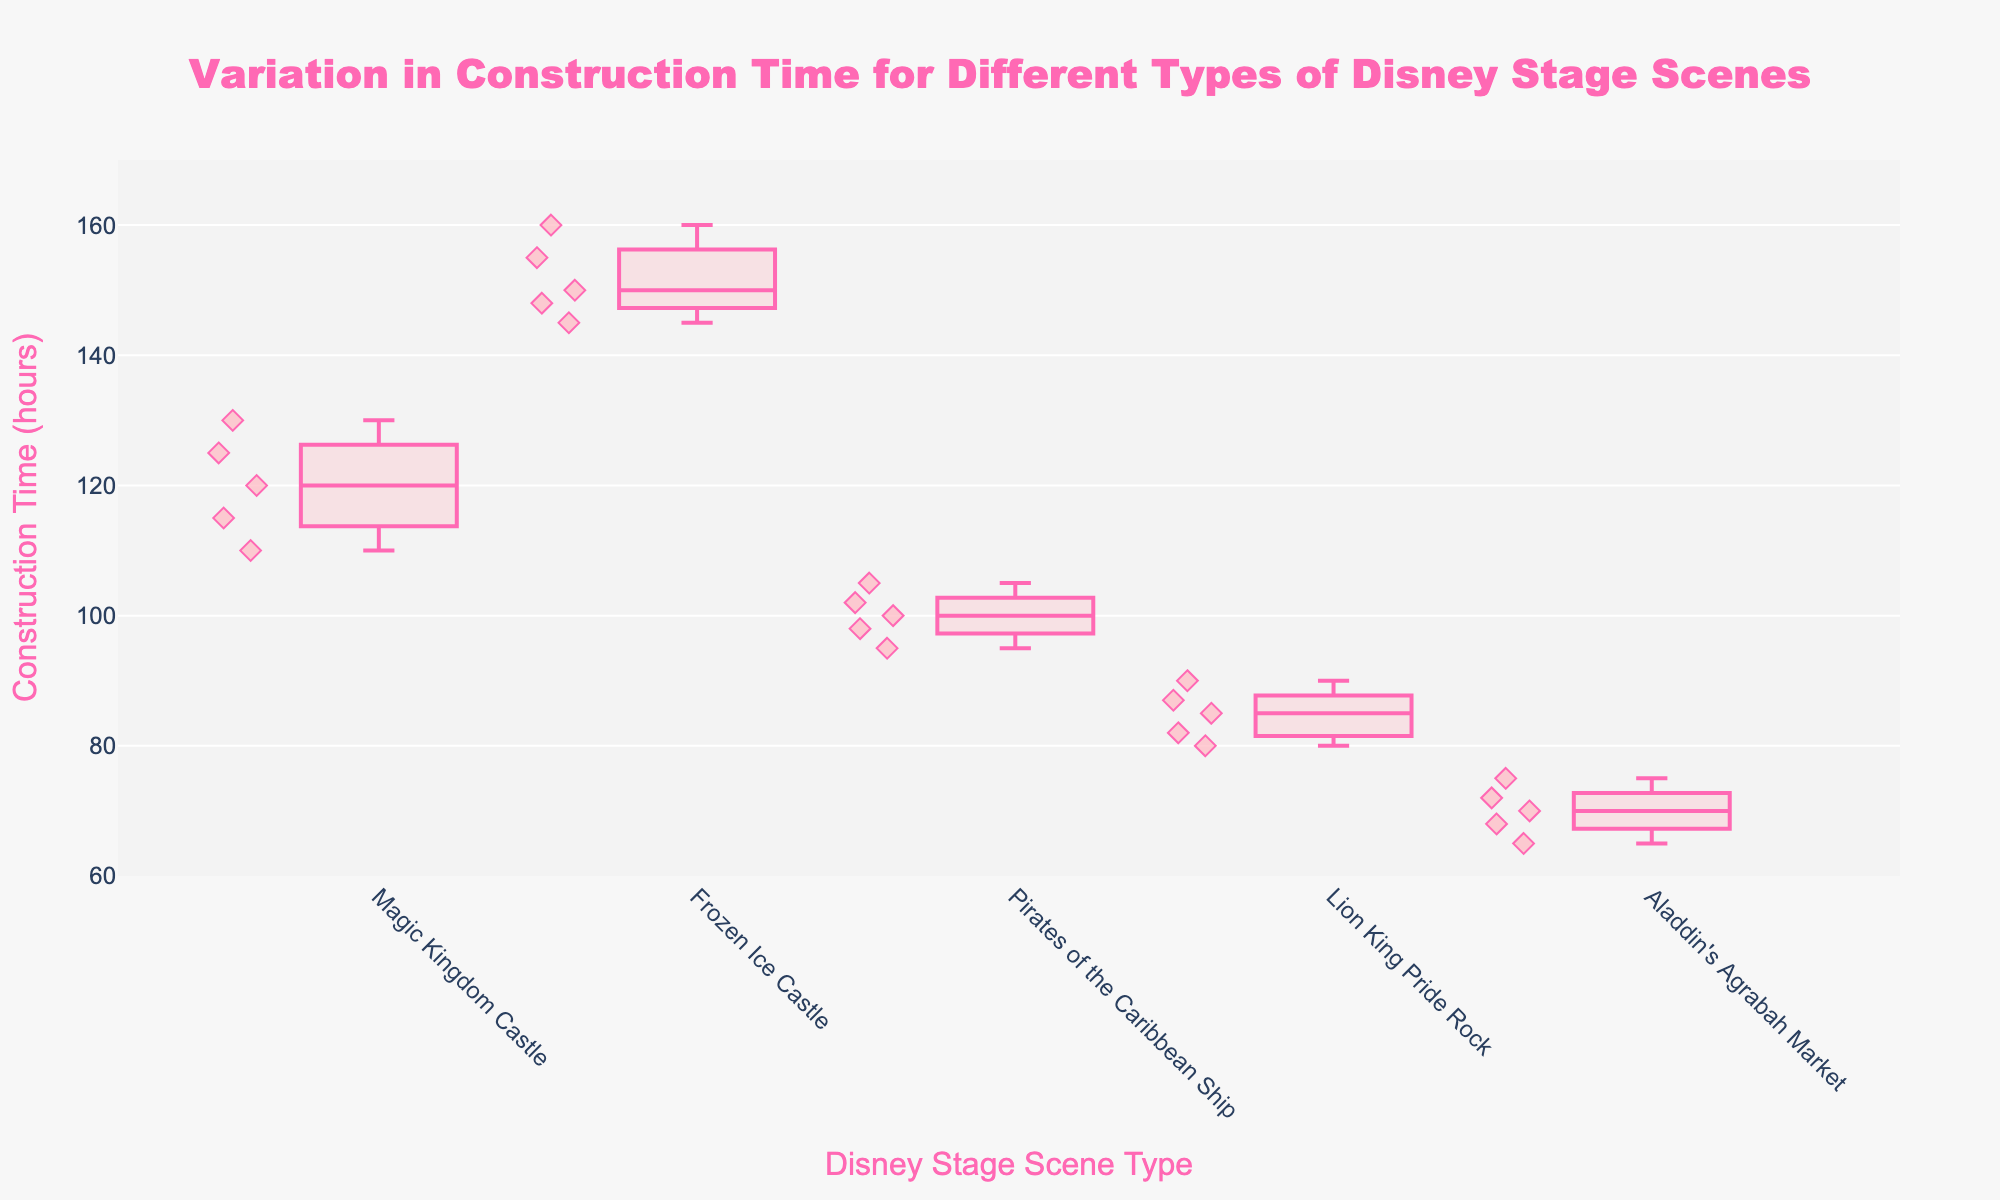What's the title of the box plot? The title of the box plot can be found at the top of the figure. It reads: "Variation in Construction Time for Different Types of Disney Stage Scenes."
Answer: Variation in Construction Time for Different Types of Disney Stage Scenes How many different types of Disney stage scenes are represented in the plot? The number of different box plots corresponds to the number of stage scene types. By counting the box plots or the labels on the x-axis, we can determine that there are 5 different types.
Answer: 5 What's the median construction time for the Magic Kingdom Castle scene? The median value is indicated by the line inside the box for the Magic Kingdom Castle. This line is at approximately 120 hours.
Answer: 120 hours Which Disney stage scene has the highest median construction time? Each box has a line indicating the median. By comparing these lines, the Frozen Ice Castle has the highest median, around 150 hours.
Answer: Frozen Ice Castle Which Disney stage scene shows the most variation in construction time? The variation in construction time can be judged by the length of the boxes and whiskers. The Magic Kingdom Castle has the widest range from its lower to upper whiskers, indicating the most variation.
Answer: Magic Kingdom Castle What's the interquartile range (IQR) for the Frozen Ice Castle scene? The IQR is the difference between the upper quartile (Q3) and the lower quartile (Q1). For the Frozen Ice Castle, Q3 is about 155 hours and Q1 is about 148 hours, so IQR is 155 - 148 = 7 hours.
Answer: 7 hours For which scene are there some data points that fall outside the whiskers? Data points outside the whiskers are considered outliers. The plot shows that the Magic Kingdom Castle has such points outside its whiskers.
Answer: Magic Kingdom Castle What is the range of construction times for the Lion King Pride Rock scene? The range is the difference between the maximum and minimum values. For the Lion King Pride Rock, the maximum is about 90 hours and the minimum is about 80 hours; thus, the range is 90 - 80 = 10 hours.
Answer: 10 hours Compare the construction time of Aladdin's Agrabah Market to Pirates of the Caribbean Ship. Which requires less time on average? By examining the median lines, the median construction time for Aladdin's Agrabah Market is around 70 hours, whereas for Pirates of the Caribbean Ship it is around 100 hours. Thus, Aladdin's Agrabah Market requires less time on average.
Answer: Aladdin's Agrabah Market What is the construction time for the outlier point in the Magic Kingdom Castle scene? The outlier points are shown as individual markers outside the whiskers of the box. For the Magic Kingdom Castle, there’s a point around 130 hours.
Answer: 130 hours 